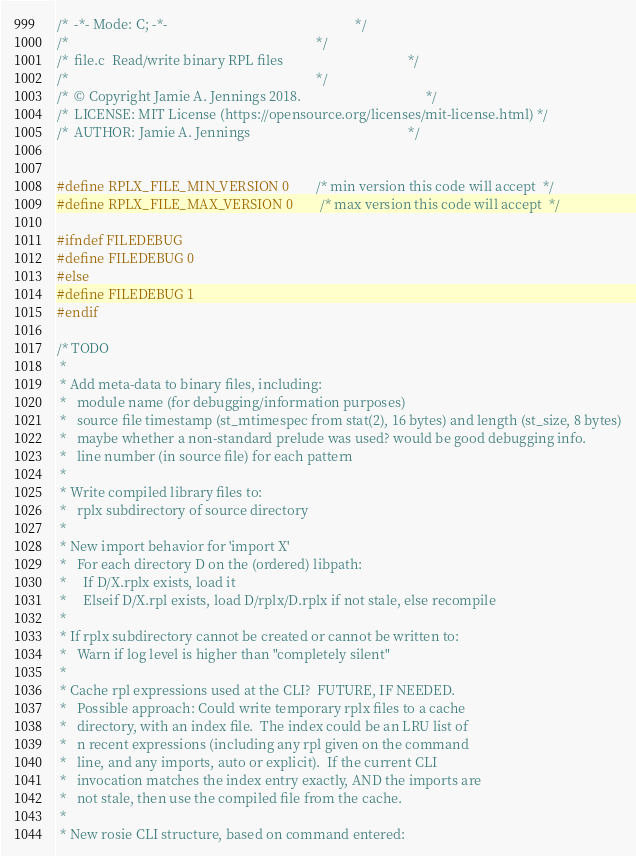<code> <loc_0><loc_0><loc_500><loc_500><_C_>/*  -*- Mode: C; -*-                                                        */
/*                                                                          */
/*  file.c  Read/write binary RPL files                                     */
/*                                                                          */
/*  © Copyright Jamie A. Jennings 2018.                                     */
/*  LICENSE: MIT License (https://opensource.org/licenses/mit-license.html) */
/*  AUTHOR: Jamie A. Jennings                                               */


#define RPLX_FILE_MIN_VERSION 0	      /* min version this code will accept  */
#define RPLX_FILE_MAX_VERSION 0	      /* max version this code will accept  */

#ifndef FILEDEBUG
#define FILEDEBUG 0
#else
#define FILEDEBUG 1
#endif

/* TODO
 *
 * Add meta-data to binary files, including:
 *   module name (for debugging/information purposes)
 *   source file timestamp (st_mtimespec from stat(2), 16 bytes) and length (st_size, 8 bytes)
 *   maybe whether a non-standard prelude was used? would be good debugging info.
 *   line number (in source file) for each pattern
 *
 * Write compiled library files to:
 *   rplx subdirectory of source directory
 * 
 * New import behavior for 'import X'
 *   For each directory D on the (ordered) libpath:
 *     If D/X.rplx exists, load it
 *     Elseif D/X.rpl exists, load D/rplx/D.rplx if not stale, else recompile
 *
 * If rplx subdirectory cannot be created or cannot be written to:
 *   Warn if log level is higher than "completely silent"
 *
 * Cache rpl expressions used at the CLI?  FUTURE, IF NEEDED.
 *   Possible approach: Could write temporary rplx files to a cache
 *   directory, with an index file.  The index could be an LRU list of
 *   n recent expressions (including any rpl given on the command
 *   line, and any imports, auto or explicit).  If the current CLI
 *   invocation matches the index entry exactly, AND the imports are
 *   not stale, then use the compiled file from the cache.
 *
 * New rosie CLI structure, based on command entered:</code> 